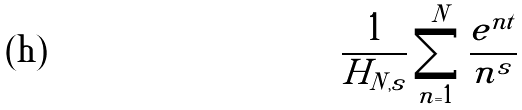Convert formula to latex. <formula><loc_0><loc_0><loc_500><loc_500>\frac { 1 } { H _ { N , s } } \sum _ { n = 1 } ^ { N } \frac { e ^ { n t } } { n ^ { s } }</formula> 